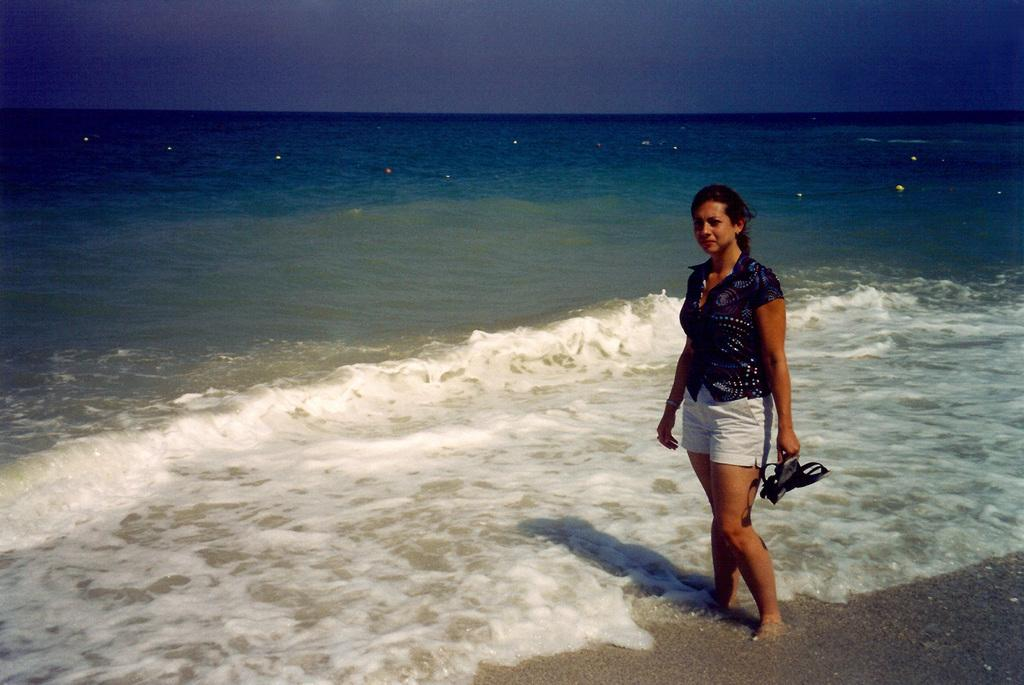Who is present in the image? There is a woman in the image. What is the woman doing in the image? The woman is standing in the image. What is the woman holding in her hand? The woman is holding an object in her hand. What can be seen in the background of the image? Water and the sky are visible in the background of the image. How many boats are visible in the image? There are no boats present in the image. What type of flame can be seen near the woman in the image? There is no flame present in the image. 